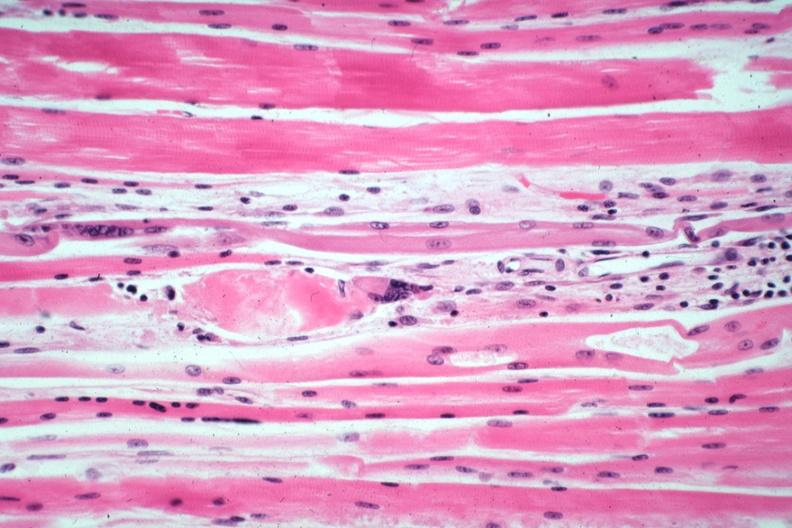s muscle present?
Answer the question using a single word or phrase. Yes 